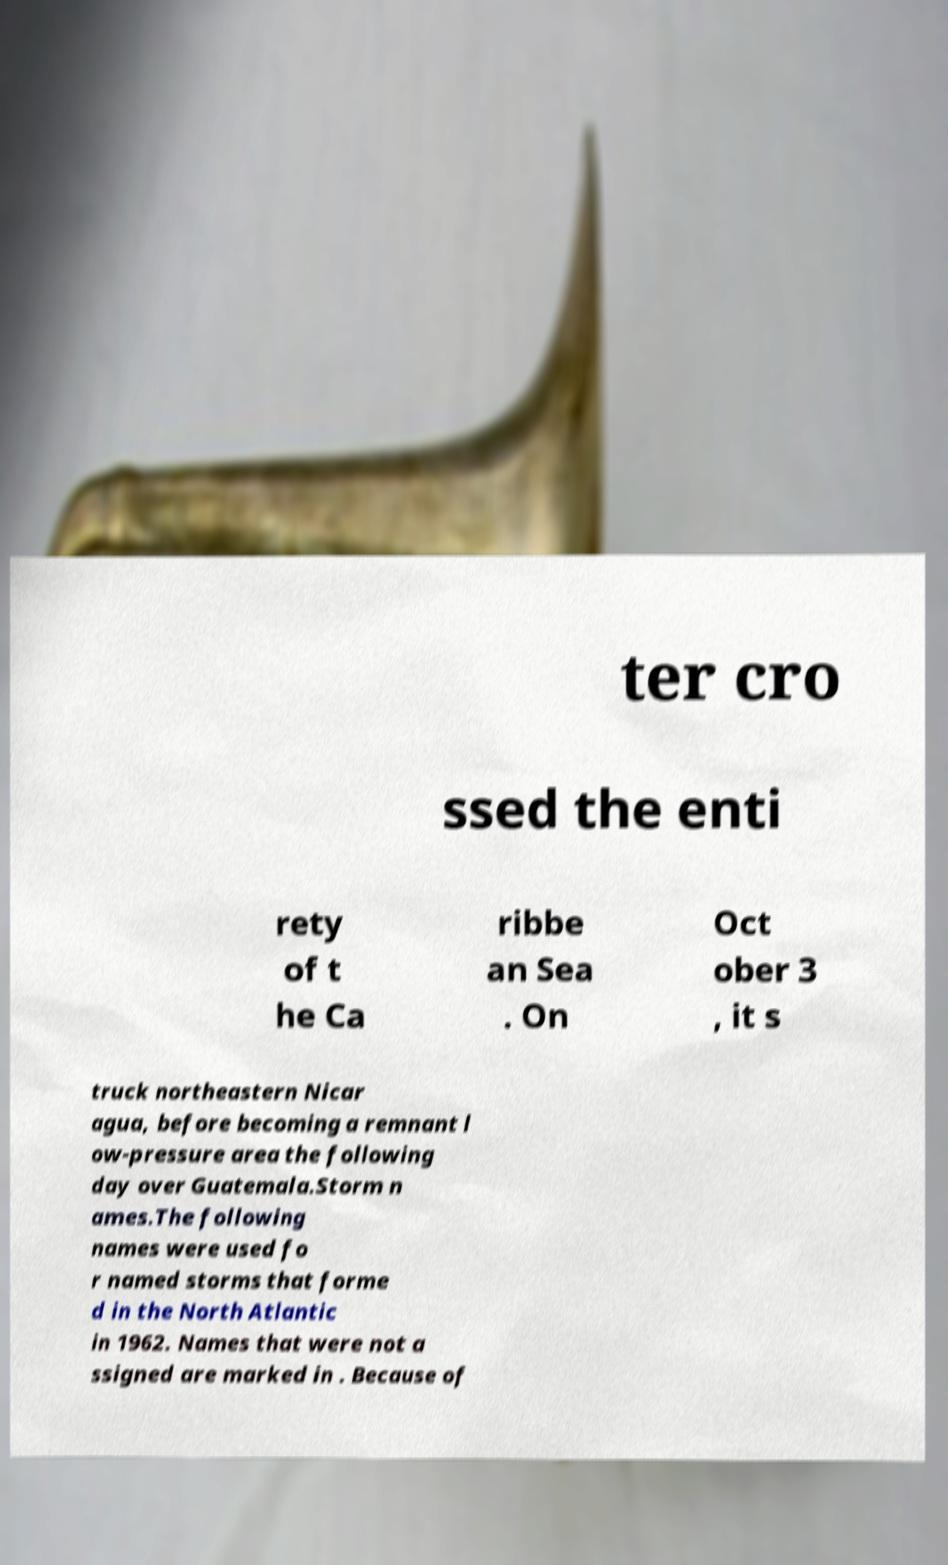I need the written content from this picture converted into text. Can you do that? ter cro ssed the enti rety of t he Ca ribbe an Sea . On Oct ober 3 , it s truck northeastern Nicar agua, before becoming a remnant l ow-pressure area the following day over Guatemala.Storm n ames.The following names were used fo r named storms that forme d in the North Atlantic in 1962. Names that were not a ssigned are marked in . Because of 